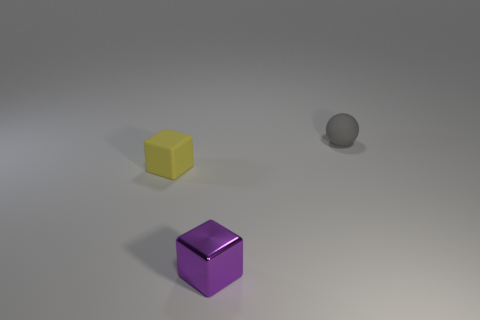Are the tiny yellow cube and the small purple block made of the same material?
Provide a short and direct response. No. What size is the yellow matte object that is the same shape as the small purple object?
Keep it short and to the point. Small. What number of objects are either tiny objects behind the small yellow thing or small rubber cubes that are behind the tiny purple metal block?
Your response must be concise. 2. Is the number of yellow matte cubes less than the number of big red shiny blocks?
Provide a succinct answer. No. Do the shiny block and the cube that is left of the purple metal object have the same size?
Ensure brevity in your answer.  Yes. How many shiny things are tiny yellow blocks or red cylinders?
Make the answer very short. 0. Are there more small gray spheres than large purple objects?
Your answer should be very brief. Yes. The thing that is on the right side of the block in front of the matte block is what shape?
Ensure brevity in your answer.  Sphere. There is a tiny matte object to the right of the small rubber thing left of the metallic block; is there a gray rubber ball on the left side of it?
Ensure brevity in your answer.  No. There is a metallic block that is the same size as the yellow rubber cube; what is its color?
Provide a short and direct response. Purple. 